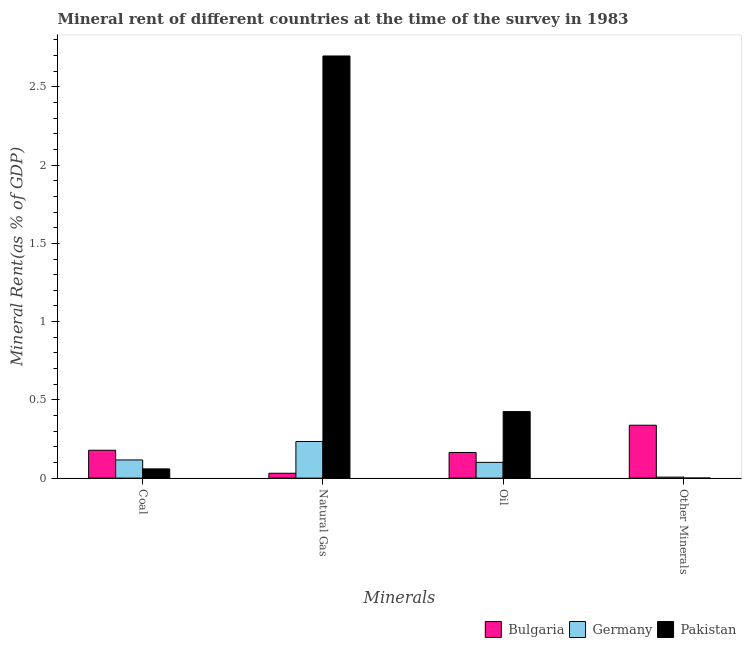How many different coloured bars are there?
Your response must be concise. 3. Are the number of bars per tick equal to the number of legend labels?
Your answer should be compact. Yes. How many bars are there on the 2nd tick from the left?
Your response must be concise. 3. What is the label of the 3rd group of bars from the left?
Offer a terse response. Oil. What is the natural gas rent in Pakistan?
Make the answer very short. 2.7. Across all countries, what is the maximum oil rent?
Your response must be concise. 0.43. Across all countries, what is the minimum oil rent?
Provide a succinct answer. 0.1. In which country was the oil rent maximum?
Your answer should be compact. Pakistan. In which country was the  rent of other minerals minimum?
Your response must be concise. Pakistan. What is the total coal rent in the graph?
Ensure brevity in your answer.  0.35. What is the difference between the oil rent in Germany and that in Pakistan?
Provide a short and direct response. -0.32. What is the difference between the oil rent in Germany and the  rent of other minerals in Pakistan?
Offer a very short reply. 0.1. What is the average oil rent per country?
Provide a succinct answer. 0.23. What is the difference between the  rent of other minerals and oil rent in Pakistan?
Provide a succinct answer. -0.42. In how many countries, is the  rent of other minerals greater than 2.5 %?
Provide a short and direct response. 0. What is the ratio of the oil rent in Bulgaria to that in Pakistan?
Your answer should be very brief. 0.39. Is the difference between the  rent of other minerals in Bulgaria and Pakistan greater than the difference between the natural gas rent in Bulgaria and Pakistan?
Ensure brevity in your answer.  Yes. What is the difference between the highest and the second highest oil rent?
Make the answer very short. 0.26. What is the difference between the highest and the lowest natural gas rent?
Offer a very short reply. 2.67. In how many countries, is the  rent of other minerals greater than the average  rent of other minerals taken over all countries?
Ensure brevity in your answer.  1. Is it the case that in every country, the sum of the coal rent and  rent of other minerals is greater than the sum of natural gas rent and oil rent?
Your response must be concise. No. What does the 2nd bar from the left in Other Minerals represents?
Your response must be concise. Germany. What does the 3rd bar from the right in Coal represents?
Offer a very short reply. Bulgaria. How many bars are there?
Your answer should be compact. 12. Are all the bars in the graph horizontal?
Ensure brevity in your answer.  No. Does the graph contain grids?
Your answer should be very brief. No. How many legend labels are there?
Your response must be concise. 3. How are the legend labels stacked?
Make the answer very short. Horizontal. What is the title of the graph?
Your answer should be very brief. Mineral rent of different countries at the time of the survey in 1983. What is the label or title of the X-axis?
Offer a very short reply. Minerals. What is the label or title of the Y-axis?
Offer a terse response. Mineral Rent(as % of GDP). What is the Mineral Rent(as % of GDP) of Bulgaria in Coal?
Offer a terse response. 0.18. What is the Mineral Rent(as % of GDP) in Germany in Coal?
Provide a succinct answer. 0.12. What is the Mineral Rent(as % of GDP) in Pakistan in Coal?
Your response must be concise. 0.06. What is the Mineral Rent(as % of GDP) of Bulgaria in Natural Gas?
Provide a short and direct response. 0.03. What is the Mineral Rent(as % of GDP) of Germany in Natural Gas?
Provide a short and direct response. 0.23. What is the Mineral Rent(as % of GDP) of Pakistan in Natural Gas?
Offer a very short reply. 2.7. What is the Mineral Rent(as % of GDP) of Bulgaria in Oil?
Your response must be concise. 0.16. What is the Mineral Rent(as % of GDP) of Germany in Oil?
Your response must be concise. 0.1. What is the Mineral Rent(as % of GDP) in Pakistan in Oil?
Provide a short and direct response. 0.43. What is the Mineral Rent(as % of GDP) of Bulgaria in Other Minerals?
Your answer should be compact. 0.34. What is the Mineral Rent(as % of GDP) in Germany in Other Minerals?
Your answer should be very brief. 0.01. What is the Mineral Rent(as % of GDP) in Pakistan in Other Minerals?
Offer a terse response. 0. Across all Minerals, what is the maximum Mineral Rent(as % of GDP) in Bulgaria?
Make the answer very short. 0.34. Across all Minerals, what is the maximum Mineral Rent(as % of GDP) in Germany?
Your response must be concise. 0.23. Across all Minerals, what is the maximum Mineral Rent(as % of GDP) in Pakistan?
Ensure brevity in your answer.  2.7. Across all Minerals, what is the minimum Mineral Rent(as % of GDP) in Bulgaria?
Offer a terse response. 0.03. Across all Minerals, what is the minimum Mineral Rent(as % of GDP) in Germany?
Offer a very short reply. 0.01. Across all Minerals, what is the minimum Mineral Rent(as % of GDP) of Pakistan?
Offer a very short reply. 0. What is the total Mineral Rent(as % of GDP) in Bulgaria in the graph?
Provide a succinct answer. 0.71. What is the total Mineral Rent(as % of GDP) of Germany in the graph?
Provide a short and direct response. 0.46. What is the total Mineral Rent(as % of GDP) in Pakistan in the graph?
Your answer should be compact. 3.18. What is the difference between the Mineral Rent(as % of GDP) in Bulgaria in Coal and that in Natural Gas?
Your answer should be compact. 0.15. What is the difference between the Mineral Rent(as % of GDP) in Germany in Coal and that in Natural Gas?
Make the answer very short. -0.12. What is the difference between the Mineral Rent(as % of GDP) of Pakistan in Coal and that in Natural Gas?
Provide a short and direct response. -2.64. What is the difference between the Mineral Rent(as % of GDP) in Bulgaria in Coal and that in Oil?
Your answer should be compact. 0.01. What is the difference between the Mineral Rent(as % of GDP) in Germany in Coal and that in Oil?
Your answer should be very brief. 0.02. What is the difference between the Mineral Rent(as % of GDP) in Pakistan in Coal and that in Oil?
Your answer should be compact. -0.37. What is the difference between the Mineral Rent(as % of GDP) of Bulgaria in Coal and that in Other Minerals?
Keep it short and to the point. -0.16. What is the difference between the Mineral Rent(as % of GDP) of Germany in Coal and that in Other Minerals?
Keep it short and to the point. 0.11. What is the difference between the Mineral Rent(as % of GDP) in Pakistan in Coal and that in Other Minerals?
Make the answer very short. 0.06. What is the difference between the Mineral Rent(as % of GDP) of Bulgaria in Natural Gas and that in Oil?
Offer a very short reply. -0.13. What is the difference between the Mineral Rent(as % of GDP) of Germany in Natural Gas and that in Oil?
Give a very brief answer. 0.13. What is the difference between the Mineral Rent(as % of GDP) of Pakistan in Natural Gas and that in Oil?
Make the answer very short. 2.27. What is the difference between the Mineral Rent(as % of GDP) in Bulgaria in Natural Gas and that in Other Minerals?
Give a very brief answer. -0.31. What is the difference between the Mineral Rent(as % of GDP) of Germany in Natural Gas and that in Other Minerals?
Keep it short and to the point. 0.23. What is the difference between the Mineral Rent(as % of GDP) of Pakistan in Natural Gas and that in Other Minerals?
Offer a terse response. 2.7. What is the difference between the Mineral Rent(as % of GDP) in Bulgaria in Oil and that in Other Minerals?
Give a very brief answer. -0.17. What is the difference between the Mineral Rent(as % of GDP) of Germany in Oil and that in Other Minerals?
Provide a short and direct response. 0.09. What is the difference between the Mineral Rent(as % of GDP) of Pakistan in Oil and that in Other Minerals?
Keep it short and to the point. 0.42. What is the difference between the Mineral Rent(as % of GDP) of Bulgaria in Coal and the Mineral Rent(as % of GDP) of Germany in Natural Gas?
Your answer should be compact. -0.06. What is the difference between the Mineral Rent(as % of GDP) in Bulgaria in Coal and the Mineral Rent(as % of GDP) in Pakistan in Natural Gas?
Give a very brief answer. -2.52. What is the difference between the Mineral Rent(as % of GDP) of Germany in Coal and the Mineral Rent(as % of GDP) of Pakistan in Natural Gas?
Keep it short and to the point. -2.58. What is the difference between the Mineral Rent(as % of GDP) in Bulgaria in Coal and the Mineral Rent(as % of GDP) in Germany in Oil?
Offer a very short reply. 0.08. What is the difference between the Mineral Rent(as % of GDP) of Bulgaria in Coal and the Mineral Rent(as % of GDP) of Pakistan in Oil?
Your answer should be very brief. -0.25. What is the difference between the Mineral Rent(as % of GDP) of Germany in Coal and the Mineral Rent(as % of GDP) of Pakistan in Oil?
Provide a succinct answer. -0.31. What is the difference between the Mineral Rent(as % of GDP) of Bulgaria in Coal and the Mineral Rent(as % of GDP) of Germany in Other Minerals?
Give a very brief answer. 0.17. What is the difference between the Mineral Rent(as % of GDP) of Bulgaria in Coal and the Mineral Rent(as % of GDP) of Pakistan in Other Minerals?
Your answer should be compact. 0.18. What is the difference between the Mineral Rent(as % of GDP) of Germany in Coal and the Mineral Rent(as % of GDP) of Pakistan in Other Minerals?
Your answer should be very brief. 0.12. What is the difference between the Mineral Rent(as % of GDP) in Bulgaria in Natural Gas and the Mineral Rent(as % of GDP) in Germany in Oil?
Offer a terse response. -0.07. What is the difference between the Mineral Rent(as % of GDP) of Bulgaria in Natural Gas and the Mineral Rent(as % of GDP) of Pakistan in Oil?
Your answer should be very brief. -0.39. What is the difference between the Mineral Rent(as % of GDP) in Germany in Natural Gas and the Mineral Rent(as % of GDP) in Pakistan in Oil?
Make the answer very short. -0.19. What is the difference between the Mineral Rent(as % of GDP) in Bulgaria in Natural Gas and the Mineral Rent(as % of GDP) in Germany in Other Minerals?
Your response must be concise. 0.02. What is the difference between the Mineral Rent(as % of GDP) in Bulgaria in Natural Gas and the Mineral Rent(as % of GDP) in Pakistan in Other Minerals?
Offer a terse response. 0.03. What is the difference between the Mineral Rent(as % of GDP) in Germany in Natural Gas and the Mineral Rent(as % of GDP) in Pakistan in Other Minerals?
Give a very brief answer. 0.23. What is the difference between the Mineral Rent(as % of GDP) of Bulgaria in Oil and the Mineral Rent(as % of GDP) of Germany in Other Minerals?
Offer a very short reply. 0.16. What is the difference between the Mineral Rent(as % of GDP) of Bulgaria in Oil and the Mineral Rent(as % of GDP) of Pakistan in Other Minerals?
Offer a terse response. 0.16. What is the difference between the Mineral Rent(as % of GDP) of Germany in Oil and the Mineral Rent(as % of GDP) of Pakistan in Other Minerals?
Provide a succinct answer. 0.1. What is the average Mineral Rent(as % of GDP) in Bulgaria per Minerals?
Ensure brevity in your answer.  0.18. What is the average Mineral Rent(as % of GDP) of Germany per Minerals?
Offer a terse response. 0.11. What is the average Mineral Rent(as % of GDP) of Pakistan per Minerals?
Your answer should be very brief. 0.8. What is the difference between the Mineral Rent(as % of GDP) in Bulgaria and Mineral Rent(as % of GDP) in Germany in Coal?
Ensure brevity in your answer.  0.06. What is the difference between the Mineral Rent(as % of GDP) in Bulgaria and Mineral Rent(as % of GDP) in Pakistan in Coal?
Make the answer very short. 0.12. What is the difference between the Mineral Rent(as % of GDP) in Germany and Mineral Rent(as % of GDP) in Pakistan in Coal?
Ensure brevity in your answer.  0.06. What is the difference between the Mineral Rent(as % of GDP) in Bulgaria and Mineral Rent(as % of GDP) in Germany in Natural Gas?
Your answer should be compact. -0.2. What is the difference between the Mineral Rent(as % of GDP) in Bulgaria and Mineral Rent(as % of GDP) in Pakistan in Natural Gas?
Make the answer very short. -2.67. What is the difference between the Mineral Rent(as % of GDP) of Germany and Mineral Rent(as % of GDP) of Pakistan in Natural Gas?
Your response must be concise. -2.46. What is the difference between the Mineral Rent(as % of GDP) of Bulgaria and Mineral Rent(as % of GDP) of Germany in Oil?
Provide a short and direct response. 0.06. What is the difference between the Mineral Rent(as % of GDP) in Bulgaria and Mineral Rent(as % of GDP) in Pakistan in Oil?
Keep it short and to the point. -0.26. What is the difference between the Mineral Rent(as % of GDP) of Germany and Mineral Rent(as % of GDP) of Pakistan in Oil?
Offer a terse response. -0.32. What is the difference between the Mineral Rent(as % of GDP) in Bulgaria and Mineral Rent(as % of GDP) in Germany in Other Minerals?
Your answer should be very brief. 0.33. What is the difference between the Mineral Rent(as % of GDP) of Bulgaria and Mineral Rent(as % of GDP) of Pakistan in Other Minerals?
Ensure brevity in your answer.  0.34. What is the difference between the Mineral Rent(as % of GDP) of Germany and Mineral Rent(as % of GDP) of Pakistan in Other Minerals?
Provide a succinct answer. 0.01. What is the ratio of the Mineral Rent(as % of GDP) in Bulgaria in Coal to that in Natural Gas?
Offer a very short reply. 5.73. What is the ratio of the Mineral Rent(as % of GDP) of Germany in Coal to that in Natural Gas?
Your answer should be very brief. 0.5. What is the ratio of the Mineral Rent(as % of GDP) in Pakistan in Coal to that in Natural Gas?
Offer a very short reply. 0.02. What is the ratio of the Mineral Rent(as % of GDP) in Bulgaria in Coal to that in Oil?
Keep it short and to the point. 1.09. What is the ratio of the Mineral Rent(as % of GDP) of Germany in Coal to that in Oil?
Give a very brief answer. 1.15. What is the ratio of the Mineral Rent(as % of GDP) in Pakistan in Coal to that in Oil?
Make the answer very short. 0.14. What is the ratio of the Mineral Rent(as % of GDP) of Bulgaria in Coal to that in Other Minerals?
Your answer should be compact. 0.53. What is the ratio of the Mineral Rent(as % of GDP) of Germany in Coal to that in Other Minerals?
Offer a terse response. 18.39. What is the ratio of the Mineral Rent(as % of GDP) of Pakistan in Coal to that in Other Minerals?
Offer a terse response. 187.32. What is the ratio of the Mineral Rent(as % of GDP) of Bulgaria in Natural Gas to that in Oil?
Offer a terse response. 0.19. What is the ratio of the Mineral Rent(as % of GDP) in Germany in Natural Gas to that in Oil?
Ensure brevity in your answer.  2.32. What is the ratio of the Mineral Rent(as % of GDP) in Pakistan in Natural Gas to that in Oil?
Provide a short and direct response. 6.35. What is the ratio of the Mineral Rent(as % of GDP) of Bulgaria in Natural Gas to that in Other Minerals?
Ensure brevity in your answer.  0.09. What is the ratio of the Mineral Rent(as % of GDP) of Germany in Natural Gas to that in Other Minerals?
Your answer should be compact. 37.04. What is the ratio of the Mineral Rent(as % of GDP) in Pakistan in Natural Gas to that in Other Minerals?
Your response must be concise. 8564.75. What is the ratio of the Mineral Rent(as % of GDP) of Bulgaria in Oil to that in Other Minerals?
Your response must be concise. 0.48. What is the ratio of the Mineral Rent(as % of GDP) in Germany in Oil to that in Other Minerals?
Provide a succinct answer. 15.94. What is the ratio of the Mineral Rent(as % of GDP) of Pakistan in Oil to that in Other Minerals?
Provide a short and direct response. 1349.79. What is the difference between the highest and the second highest Mineral Rent(as % of GDP) of Bulgaria?
Make the answer very short. 0.16. What is the difference between the highest and the second highest Mineral Rent(as % of GDP) of Germany?
Keep it short and to the point. 0.12. What is the difference between the highest and the second highest Mineral Rent(as % of GDP) in Pakistan?
Give a very brief answer. 2.27. What is the difference between the highest and the lowest Mineral Rent(as % of GDP) in Bulgaria?
Provide a succinct answer. 0.31. What is the difference between the highest and the lowest Mineral Rent(as % of GDP) in Germany?
Ensure brevity in your answer.  0.23. What is the difference between the highest and the lowest Mineral Rent(as % of GDP) of Pakistan?
Offer a terse response. 2.7. 